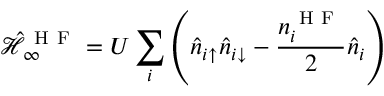<formula> <loc_0><loc_0><loc_500><loc_500>\mathcal { \hat { H } } _ { \infty } ^ { H F } = U \sum _ { i } \left ( \hat { n } _ { i \uparrow } \hat { n } _ { i \downarrow } - \frac { n _ { i } ^ { H F } } { 2 } \hat { n } _ { i } \right )</formula> 